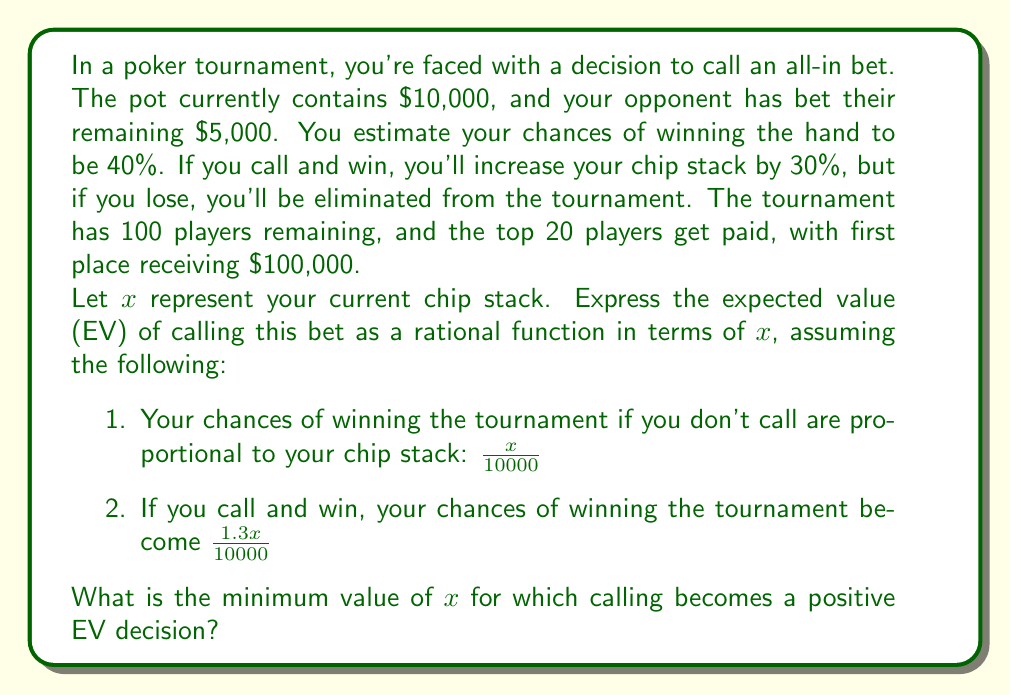Could you help me with this problem? Let's approach this step-by-step:

1) First, let's define the expected value (EV) of calling:

   $EV(\text{call}) = 0.4(1.3x \cdot \frac{100000}{10000}) + 0.6(0) - x \cdot \frac{100000}{10000}$

2) Simplify:
   $EV(\text{call}) = 52x - 10x = 42x$

3) Now, let's define the EV of not calling:
   $EV(\text{not call}) = x \cdot \frac{100000}{10000} = 10x$

4) The EV of calling is better when:
   $EV(\text{call}) > EV(\text{not call})$
   $42x > 10x$
   $32x > 0$
   $x > 0$

5) However, we also need to consider the immediate cost of calling, which is $5000. The rational function representing the net EV of calling is:

   $EV(\text{net}) = \frac{42x - 5000}{x}$

6) For calling to be positive EV, we need:
   $\frac{42x - 5000}{x} > 0$
   $42x - 5000 > 0$
   $42x > 5000$
   $x > \frac{5000}{42} \approx 119.05$

Therefore, the minimum value of $x$ for which calling becomes a positive EV decision is the ceiling of this value, which is 120.
Answer: $120 